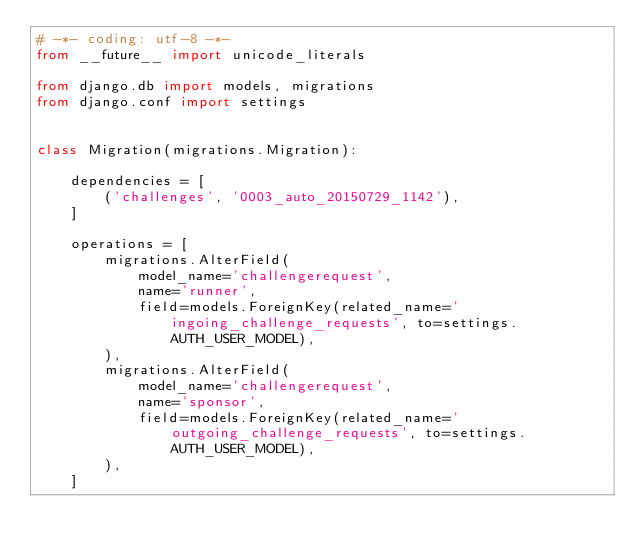Convert code to text. <code><loc_0><loc_0><loc_500><loc_500><_Python_># -*- coding: utf-8 -*-
from __future__ import unicode_literals

from django.db import models, migrations
from django.conf import settings


class Migration(migrations.Migration):

    dependencies = [
        ('challenges', '0003_auto_20150729_1142'),
    ]

    operations = [
        migrations.AlterField(
            model_name='challengerequest',
            name='runner',
            field=models.ForeignKey(related_name='ingoing_challenge_requests', to=settings.AUTH_USER_MODEL),
        ),
        migrations.AlterField(
            model_name='challengerequest',
            name='sponsor',
            field=models.ForeignKey(related_name='outgoing_challenge_requests', to=settings.AUTH_USER_MODEL),
        ),
    ]
</code> 